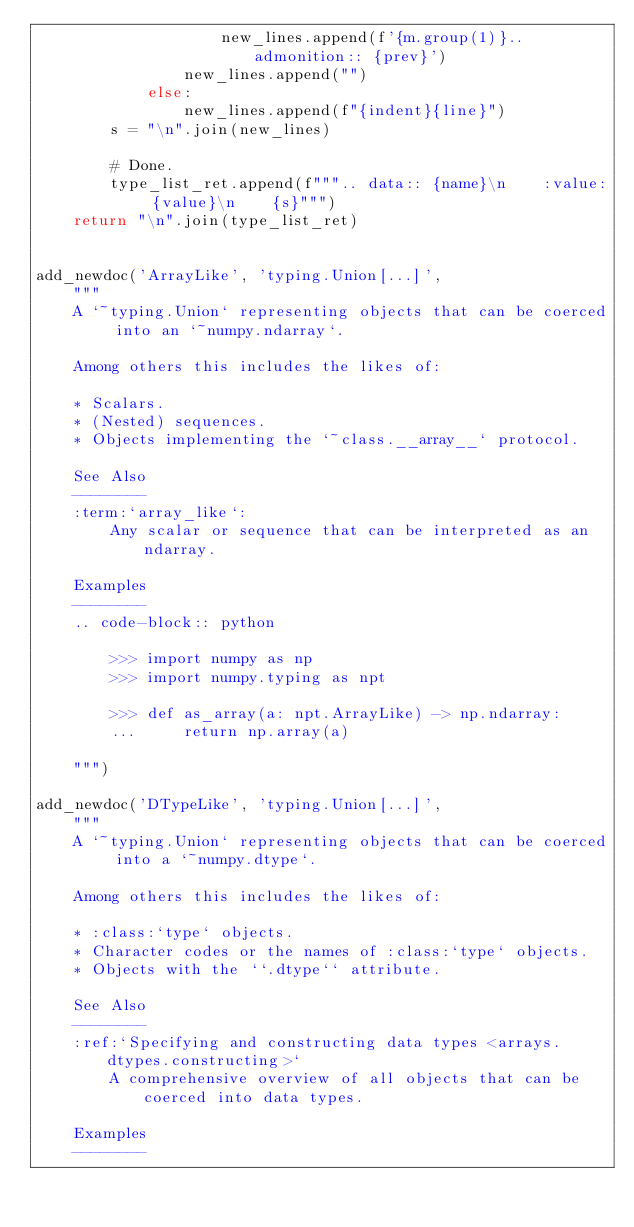Convert code to text. <code><loc_0><loc_0><loc_500><loc_500><_Python_>                    new_lines.append(f'{m.group(1)}.. admonition:: {prev}')
                new_lines.append("")
            else:
                new_lines.append(f"{indent}{line}")
        s = "\n".join(new_lines)

        # Done.
        type_list_ret.append(f""".. data:: {name}\n    :value: {value}\n    {s}""")
    return "\n".join(type_list_ret)


add_newdoc('ArrayLike', 'typing.Union[...]',
    """
    A `~typing.Union` representing objects that can be coerced into an `~numpy.ndarray`.

    Among others this includes the likes of:

    * Scalars.
    * (Nested) sequences.
    * Objects implementing the `~class.__array__` protocol.

    See Also
    --------
    :term:`array_like`:
        Any scalar or sequence that can be interpreted as an ndarray.

    Examples
    --------
    .. code-block:: python

        >>> import numpy as np
        >>> import numpy.typing as npt

        >>> def as_array(a: npt.ArrayLike) -> np.ndarray:
        ...     return np.array(a)

    """)

add_newdoc('DTypeLike', 'typing.Union[...]',
    """
    A `~typing.Union` representing objects that can be coerced into a `~numpy.dtype`.

    Among others this includes the likes of:

    * :class:`type` objects.
    * Character codes or the names of :class:`type` objects.
    * Objects with the ``.dtype`` attribute.

    See Also
    --------
    :ref:`Specifying and constructing data types <arrays.dtypes.constructing>`
        A comprehensive overview of all objects that can be coerced into data types.

    Examples
    --------</code> 